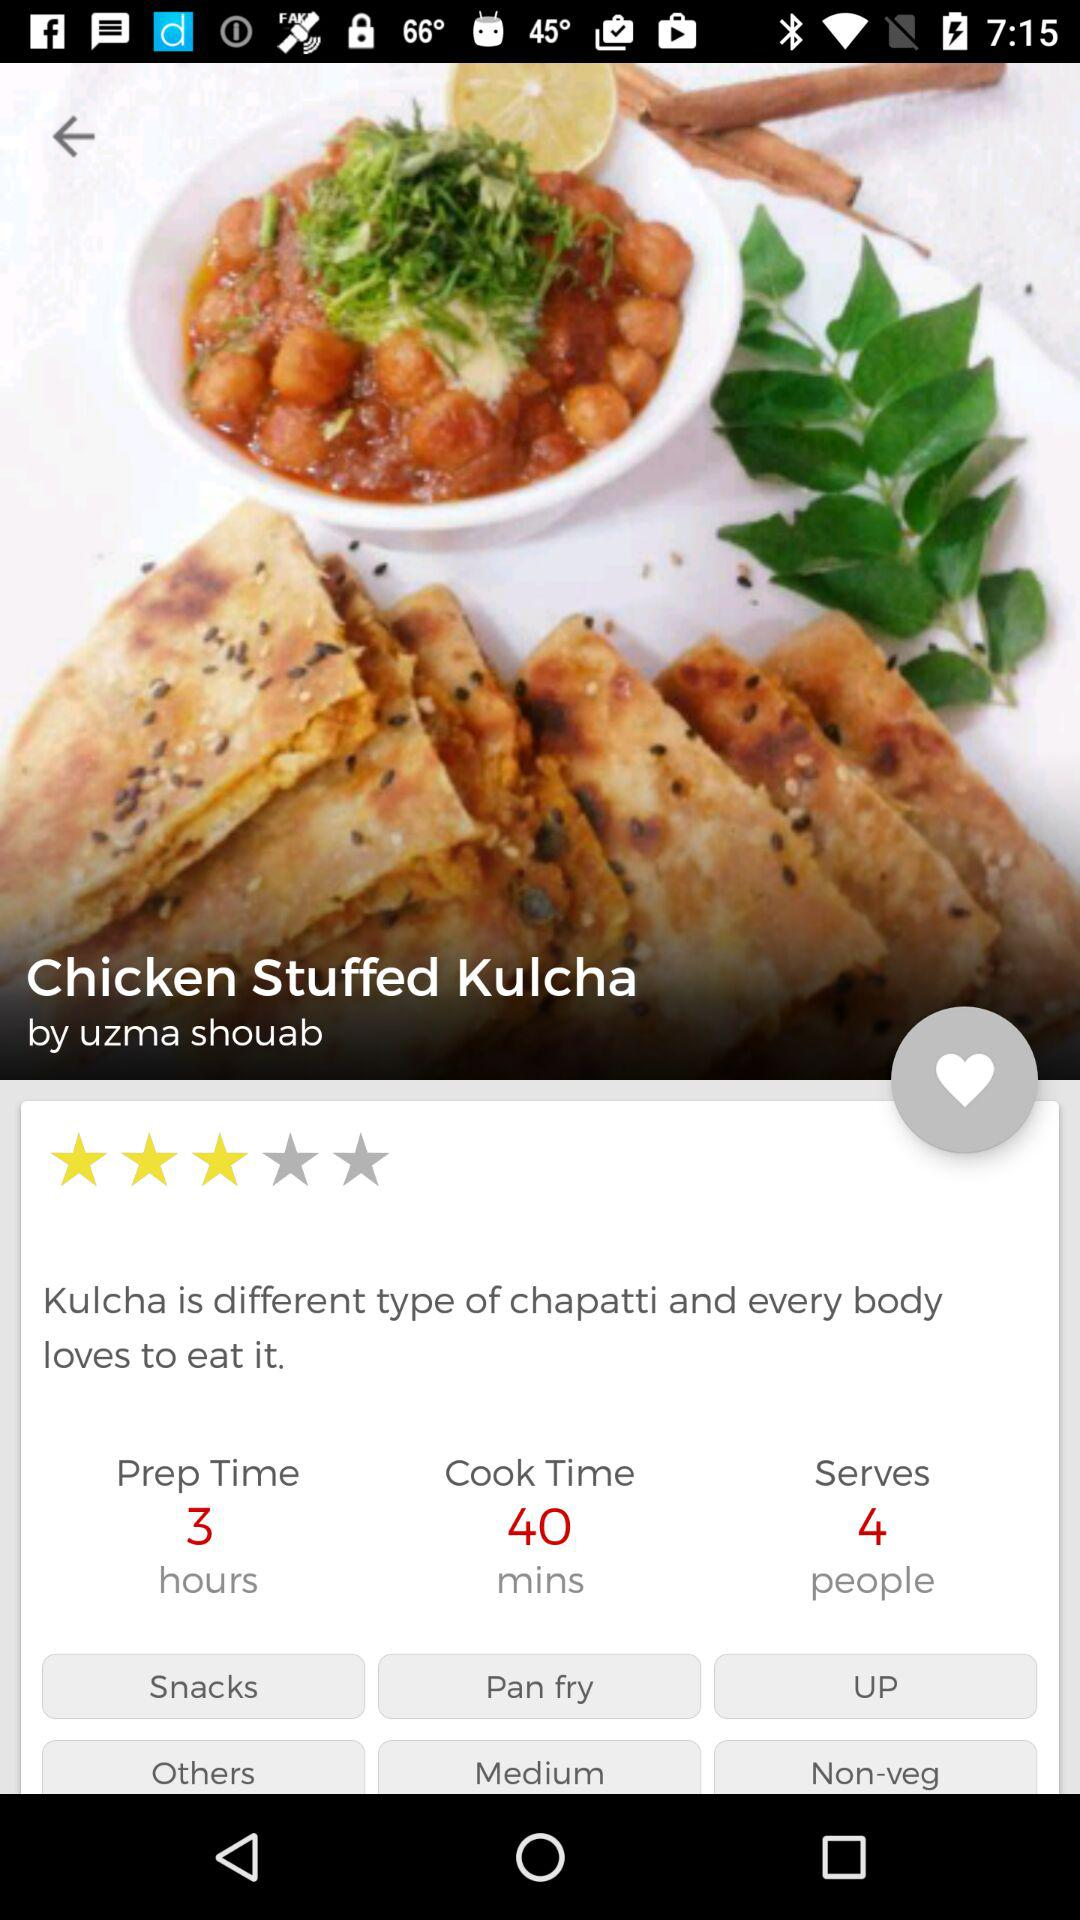What is the rating of the dish? The Chicken Stuffed Kulcha dish shown in the image has a 2-star rating according to the visible customer feedback. 